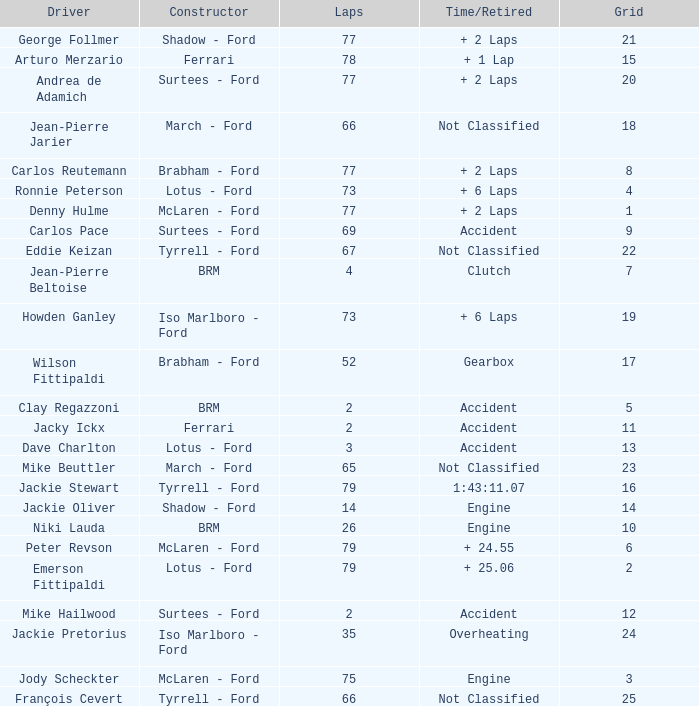How much time is required for less than 35 laps and less than 10 grids? Clutch, Accident. 